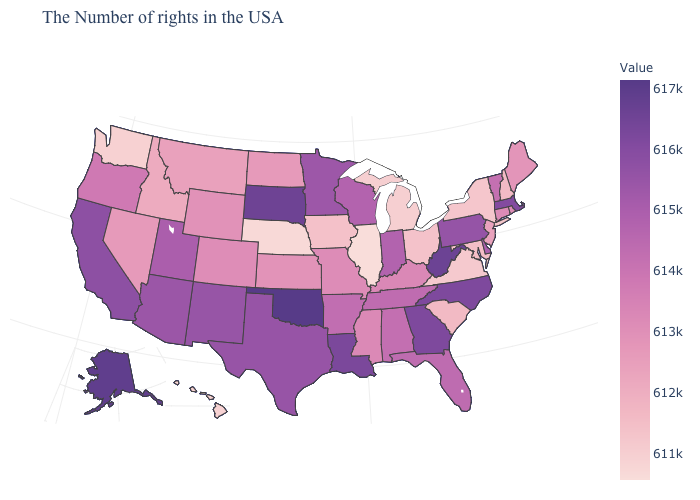Among the states that border Kansas , does Oklahoma have the highest value?
Short answer required. Yes. Does Indiana have a lower value than California?
Be succinct. Yes. Among the states that border New Jersey , does New York have the lowest value?
Give a very brief answer. Yes. Does Hawaii have the lowest value in the West?
Be succinct. Yes. Does the map have missing data?
Short answer required. No. 